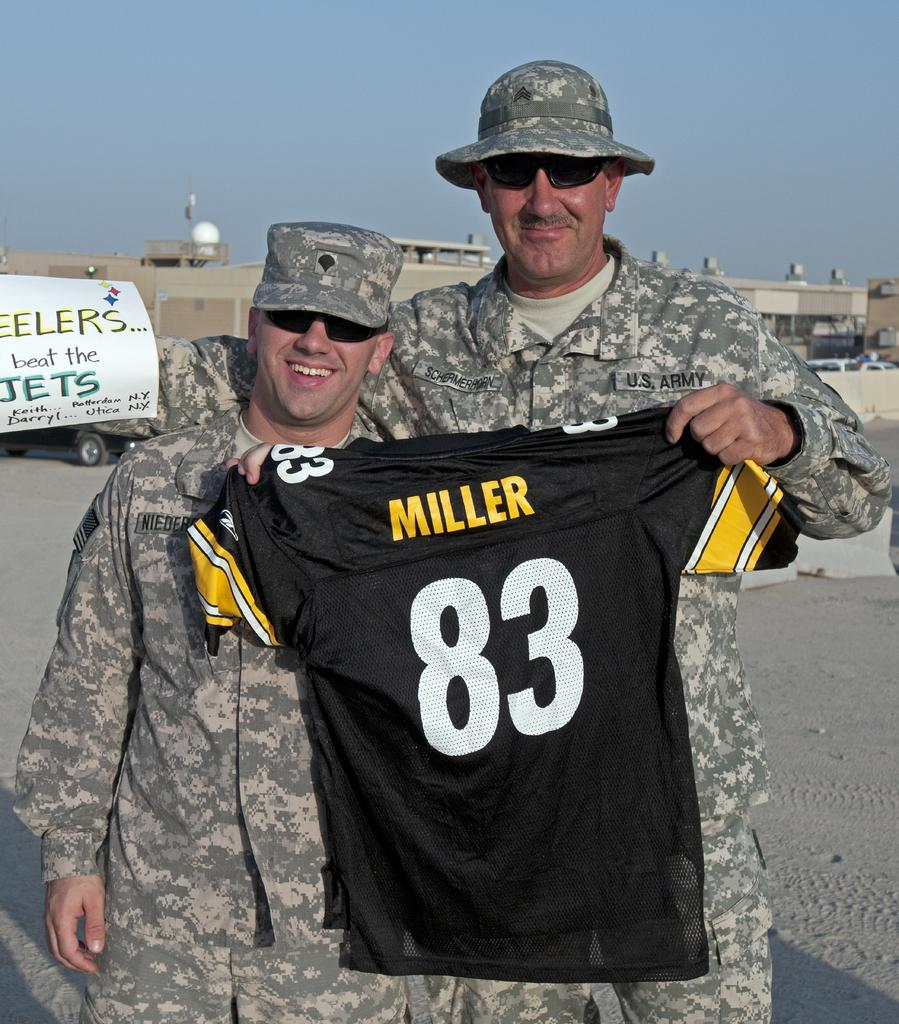<image>
Create a compact narrative representing the image presented. Two soldiers holding a black jersey that says Miller on it. 